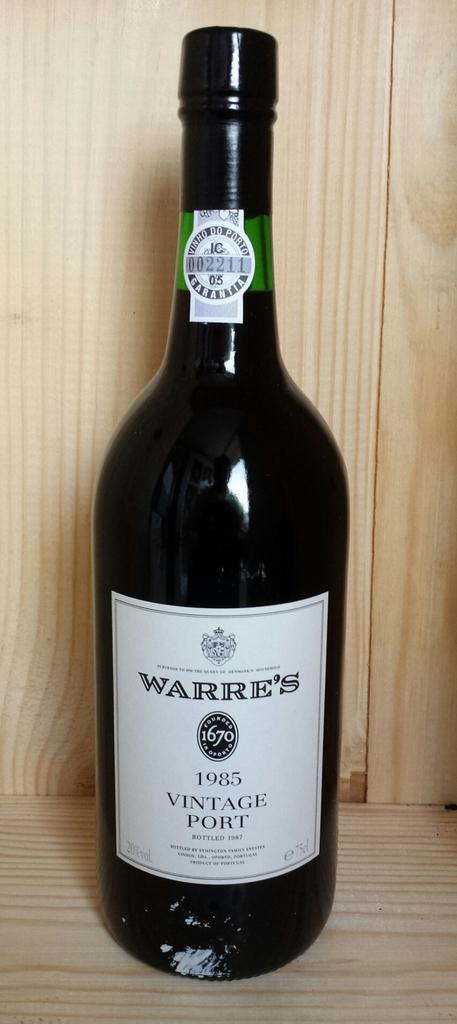What type of beverage container is visible in the image? There is a beer bottle in the image. What can be seen on the beer bottle? The beer bottle has labels on it. What type of surface is present in the image? The wooden path is present in the image. How does the giraffe compare in size to the beer bottle in the image? There is no giraffe present in the image, so it is not possible to make a comparison. 